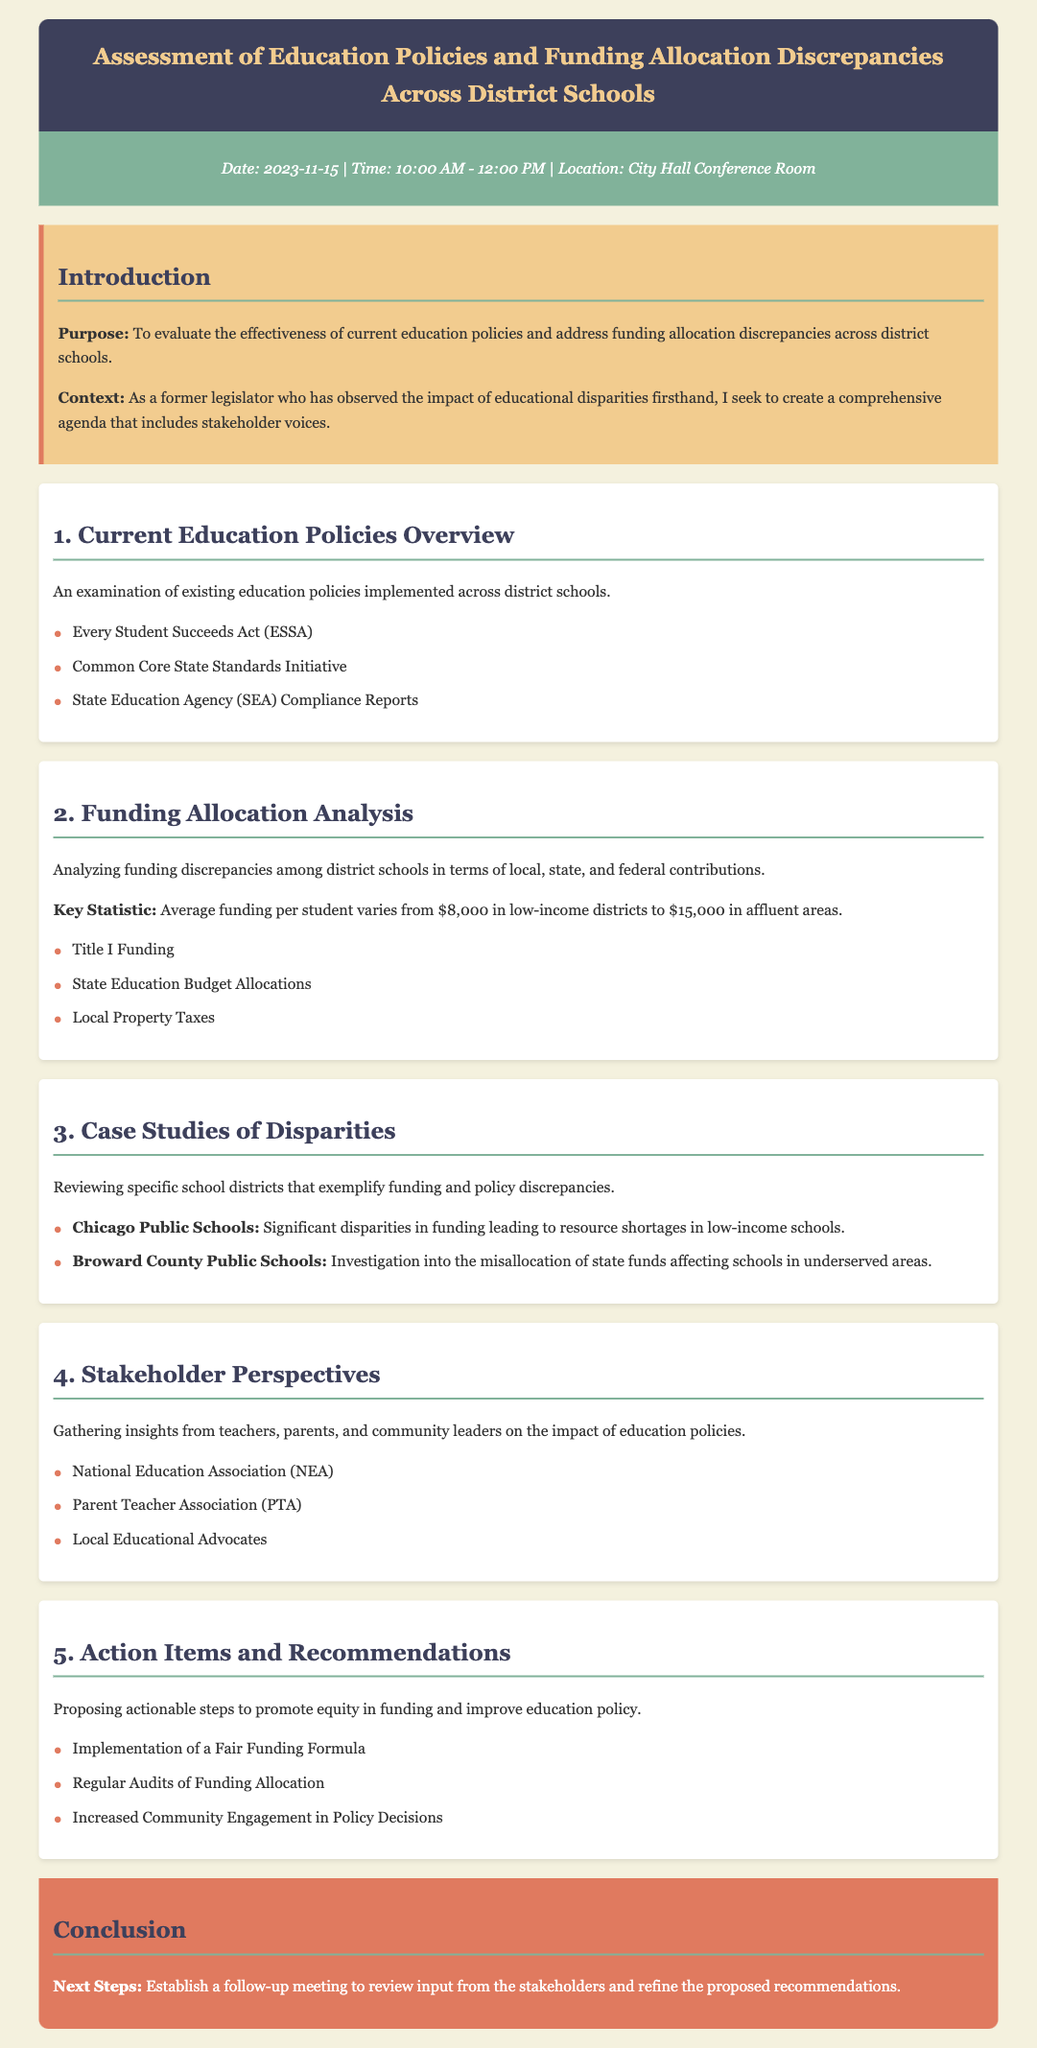What is the date of the meeting? The date is mentioned in the meta-info section of the document as 2023-11-15.
Answer: 2023-11-15 What is the time of the meeting? The time is listed in the meta-info section, running from 10:00 AM to 12:00 PM.
Answer: 10:00 AM - 12:00 PM What is the purpose of the meeting? The purpose is outlined in the introduction section of the document, stating the evaluation of education policies and funding allocation discrepancies.
Answer: To evaluate the effectiveness of current education policies and address funding allocation discrepancies across district schools What is the key statistic regarding funding per student? The document specifies the average funding per student varies from $8,000 in low-income districts to $15,000 in affluent areas.
Answer: $8,000 in low-income districts to $15,000 in affluent areas Which school district is mentioned as having significant funding disparities? The case study section lists Chicago Public Schools as an example of significant funding disparities.
Answer: Chicago Public Schools What are the stakeholders involved in gathering perspectives? The document lists groups such as the National Education Association, the Parent Teacher Association, and local educational advocates as stakeholders.
Answer: National Education Association, Parent Teacher Association, Local Educational Advocates What is one proposed action item from the recommendations section? The document includes several actionable steps, one of which is the implementation of a Fair Funding Formula.
Answer: Implementation of a Fair Funding Formula How many case studies are mentioned in the agenda? The case studies section highlights two specific school districts that illustrate funding and policy discrepancies.
Answer: Two What is the conclusion's call to action? The conclusion states that the next steps involve establishing a follow-up meeting to review input from stakeholders.
Answer: Establish a follow-up meeting 